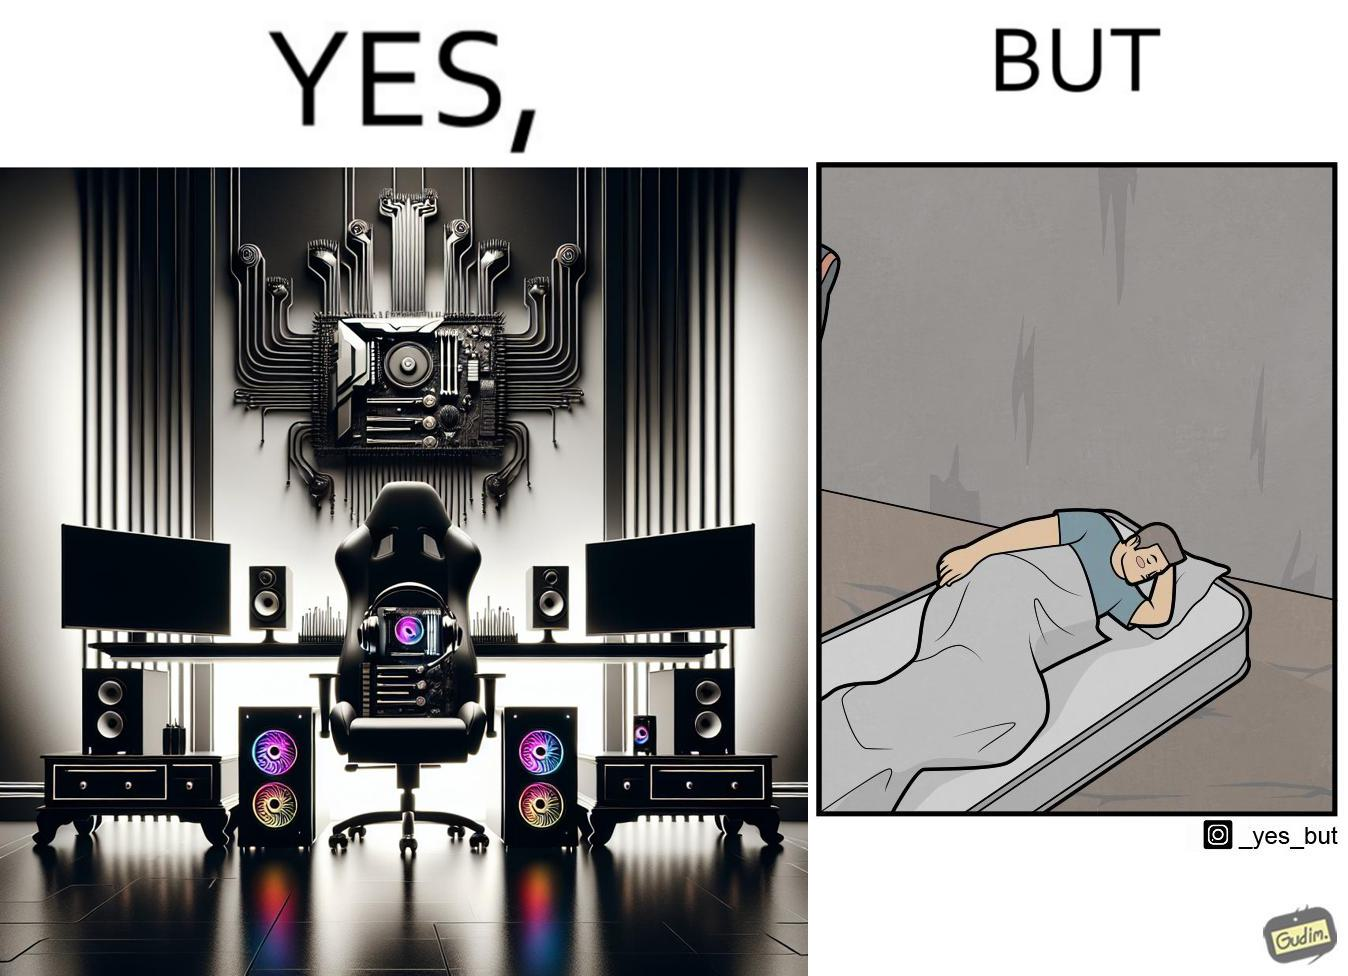What makes this image funny or satirical? The image is funny because the person has a lot of furniture for his computer but none for himself. 